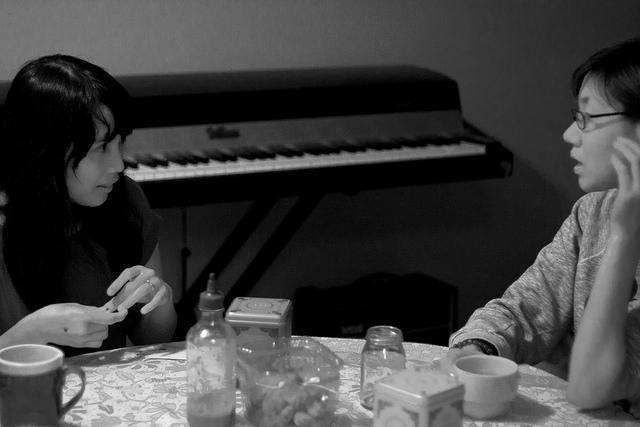How many dining tables can be seen?
Give a very brief answer. 1. How many people are in the picture?
Give a very brief answer. 2. How many bottles are there?
Give a very brief answer. 2. How many cups are there?
Give a very brief answer. 2. How many elephants can be seen?
Give a very brief answer. 0. 